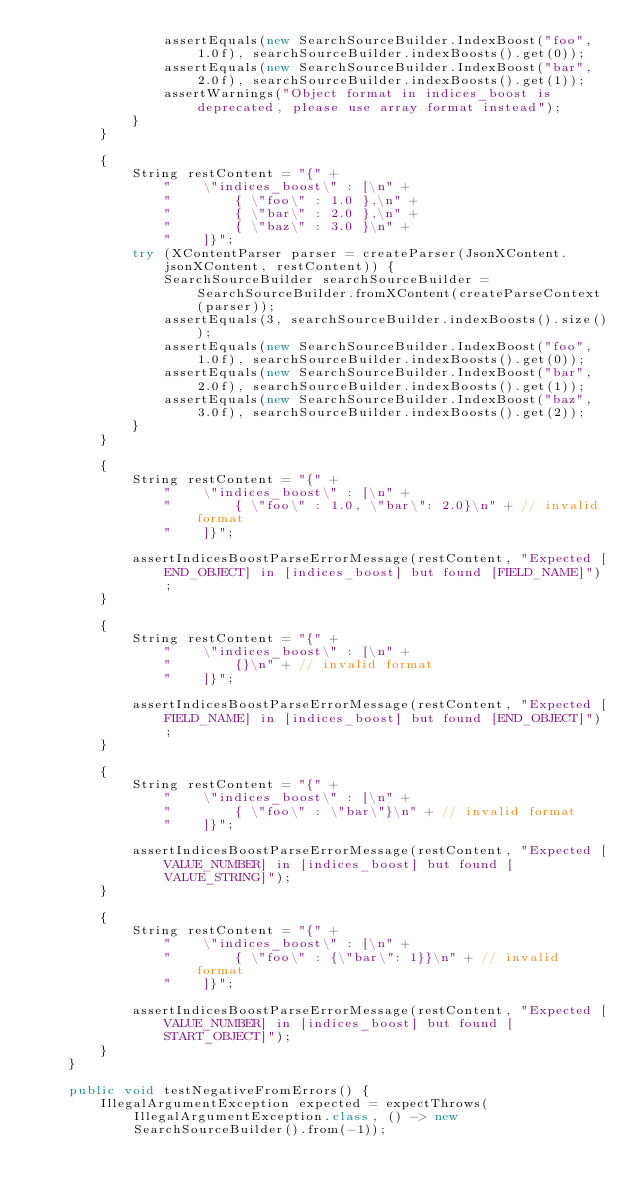Convert code to text. <code><loc_0><loc_0><loc_500><loc_500><_Java_>                assertEquals(new SearchSourceBuilder.IndexBoost("foo", 1.0f), searchSourceBuilder.indexBoosts().get(0));
                assertEquals(new SearchSourceBuilder.IndexBoost("bar", 2.0f), searchSourceBuilder.indexBoosts().get(1));
                assertWarnings("Object format in indices_boost is deprecated, please use array format instead");
            }
        }

        {
            String restContent = "{" +
                "    \"indices_boost\" : [\n" +
                "        { \"foo\" : 1.0 },\n" +
                "        { \"bar\" : 2.0 },\n" +
                "        { \"baz\" : 3.0 }\n" +
                "    ]}";
            try (XContentParser parser = createParser(JsonXContent.jsonXContent, restContent)) {
                SearchSourceBuilder searchSourceBuilder = SearchSourceBuilder.fromXContent(createParseContext(parser));
                assertEquals(3, searchSourceBuilder.indexBoosts().size());
                assertEquals(new SearchSourceBuilder.IndexBoost("foo", 1.0f), searchSourceBuilder.indexBoosts().get(0));
                assertEquals(new SearchSourceBuilder.IndexBoost("bar", 2.0f), searchSourceBuilder.indexBoosts().get(1));
                assertEquals(new SearchSourceBuilder.IndexBoost("baz", 3.0f), searchSourceBuilder.indexBoosts().get(2));
            }
        }

        {
            String restContent = "{" +
                "    \"indices_boost\" : [\n" +
                "        { \"foo\" : 1.0, \"bar\": 2.0}\n" + // invalid format
                "    ]}";

            assertIndicesBoostParseErrorMessage(restContent, "Expected [END_OBJECT] in [indices_boost] but found [FIELD_NAME]");
        }

        {
            String restContent = "{" +
                "    \"indices_boost\" : [\n" +
                "        {}\n" + // invalid format
                "    ]}";

            assertIndicesBoostParseErrorMessage(restContent, "Expected [FIELD_NAME] in [indices_boost] but found [END_OBJECT]");
        }

        {
            String restContent = "{" +
                "    \"indices_boost\" : [\n" +
                "        { \"foo\" : \"bar\"}\n" + // invalid format
                "    ]}";

            assertIndicesBoostParseErrorMessage(restContent, "Expected [VALUE_NUMBER] in [indices_boost] but found [VALUE_STRING]");
        }

        {
            String restContent = "{" +
                "    \"indices_boost\" : [\n" +
                "        { \"foo\" : {\"bar\": 1}}\n" + // invalid format
                "    ]}";

            assertIndicesBoostParseErrorMessage(restContent, "Expected [VALUE_NUMBER] in [indices_boost] but found [START_OBJECT]");
        }
    }

    public void testNegativeFromErrors() {
        IllegalArgumentException expected = expectThrows(IllegalArgumentException.class, () -> new SearchSourceBuilder().from(-1));</code> 